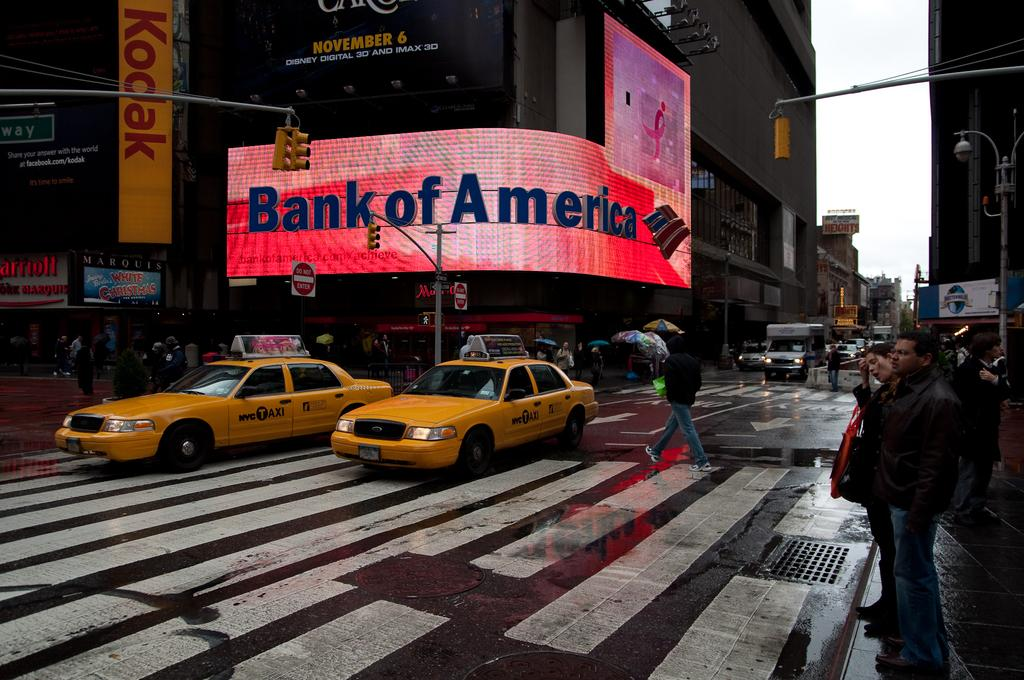<image>
Summarize the visual content of the image. Taxis on a rainy street near a Bank of America. 